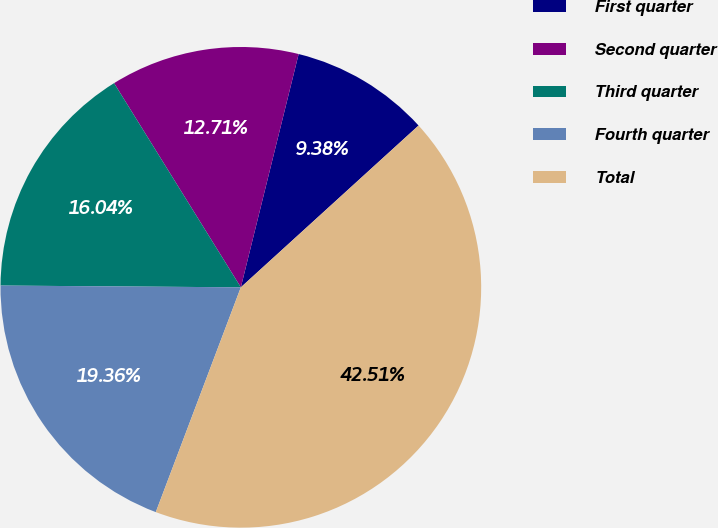<chart> <loc_0><loc_0><loc_500><loc_500><pie_chart><fcel>First quarter<fcel>Second quarter<fcel>Third quarter<fcel>Fourth quarter<fcel>Total<nl><fcel>9.38%<fcel>12.71%<fcel>16.04%<fcel>19.36%<fcel>42.51%<nl></chart> 